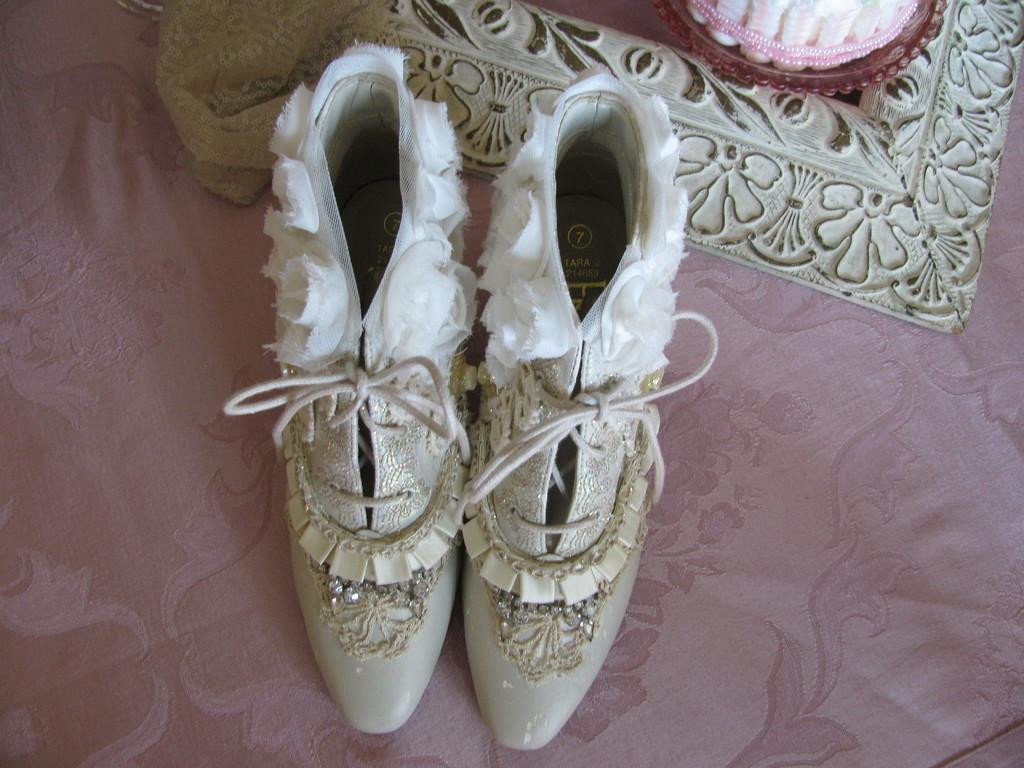What type of footwear is visible in the image? There is a pair of shoes in the image. What material is associated with the shoes in the image? The provided facts do not specify the material of the shoes. What else can be seen in the image besides the shoes? There is cloth in the image. What type of cloth is visible in the image? The provided facts do not specify the type of cloth. What role does the porter play in the battle scene depicted in the image? There is no battle scene or porter present in the image; it only features a pair of shoes and cloth. 